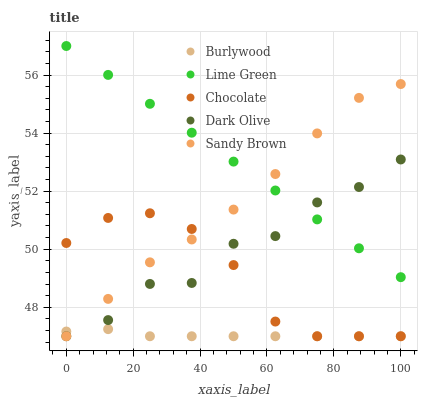Does Burlywood have the minimum area under the curve?
Answer yes or no. Yes. Does Lime Green have the maximum area under the curve?
Answer yes or no. Yes. Does Sandy Brown have the minimum area under the curve?
Answer yes or no. No. Does Sandy Brown have the maximum area under the curve?
Answer yes or no. No. Is Lime Green the smoothest?
Answer yes or no. Yes. Is Dark Olive the roughest?
Answer yes or no. Yes. Is Sandy Brown the smoothest?
Answer yes or no. No. Is Sandy Brown the roughest?
Answer yes or no. No. Does Burlywood have the lowest value?
Answer yes or no. Yes. Does Lime Green have the lowest value?
Answer yes or no. No. Does Lime Green have the highest value?
Answer yes or no. Yes. Does Sandy Brown have the highest value?
Answer yes or no. No. Is Burlywood less than Lime Green?
Answer yes or no. Yes. Is Lime Green greater than Burlywood?
Answer yes or no. Yes. Does Burlywood intersect Dark Olive?
Answer yes or no. Yes. Is Burlywood less than Dark Olive?
Answer yes or no. No. Is Burlywood greater than Dark Olive?
Answer yes or no. No. Does Burlywood intersect Lime Green?
Answer yes or no. No. 